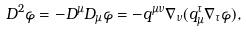<formula> <loc_0><loc_0><loc_500><loc_500>D ^ { 2 } \varphi = - D ^ { \mu } D _ { \mu } \varphi = - q ^ { \mu \nu } \nabla _ { \nu } ( q _ { \mu } ^ { \tau } \nabla _ { \tau } \varphi ) ,</formula> 